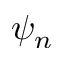Convert formula to latex. <formula><loc_0><loc_0><loc_500><loc_500>\psi _ { n }</formula> 